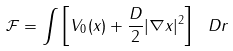<formula> <loc_0><loc_0><loc_500><loc_500>\mathcal { F } = \int \left [ V _ { 0 } ( x ) + \frac { D } { 2 } | \nabla x | ^ { 2 } \right ] \ D r</formula> 